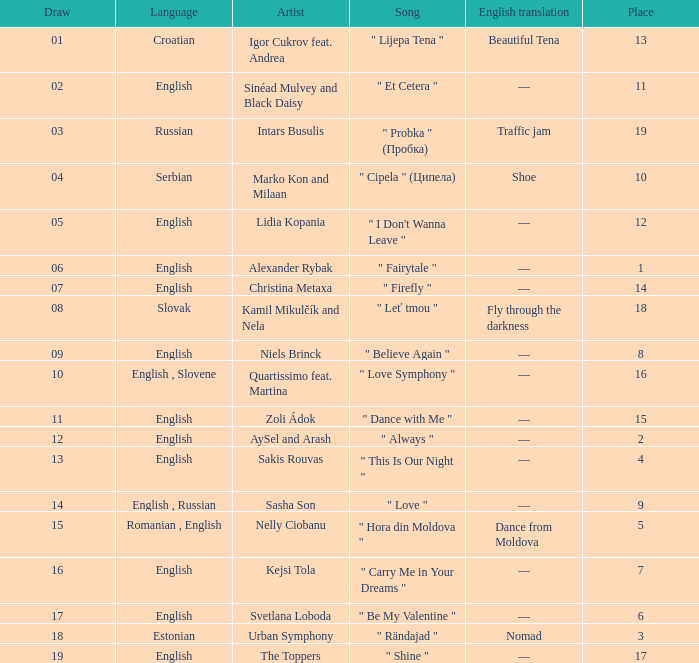When the artist is kamil mikulčík and nela and the place exceeds 18, what is the average points? None. 